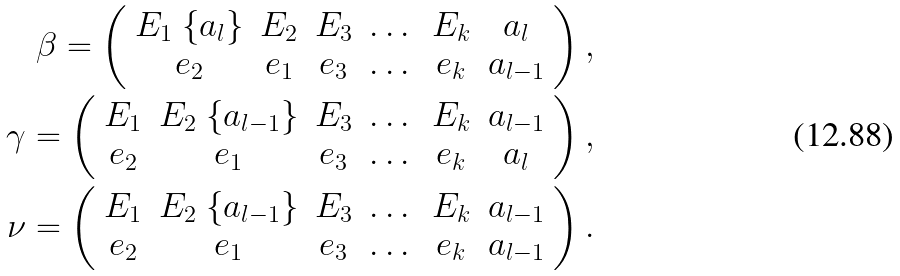Convert formula to latex. <formula><loc_0><loc_0><loc_500><loc_500>\beta = \left ( \begin{array} { c c c c c c } E _ { 1 } \ \{ a _ { l } \} & E _ { 2 } & E _ { 3 } & \dots & E _ { k } & a _ { l } \\ e _ { 2 } & e _ { 1 } & e _ { 3 } & \dots & e _ { k } & a _ { l - 1 } \end{array} \right ) , \\ \gamma = \left ( \begin{array} { c c c c c c } E _ { 1 } & E _ { 2 } \ \{ a _ { l - 1 } \} & E _ { 3 } & \dots & E _ { k } & a _ { l - 1 } \\ e _ { 2 } & e _ { 1 } & e _ { 3 } & \dots & e _ { k } & a _ { l } \end{array} \right ) , \\ \nu = \left ( \begin{array} { c c c c c c } E _ { 1 } & E _ { 2 } \ \{ a _ { l - 1 } \} & E _ { 3 } & \dots & E _ { k } & a _ { l - 1 } \\ e _ { 2 } & e _ { 1 } & e _ { 3 } & \dots & e _ { k } & a _ { l - 1 } \end{array} \right ) .</formula> 